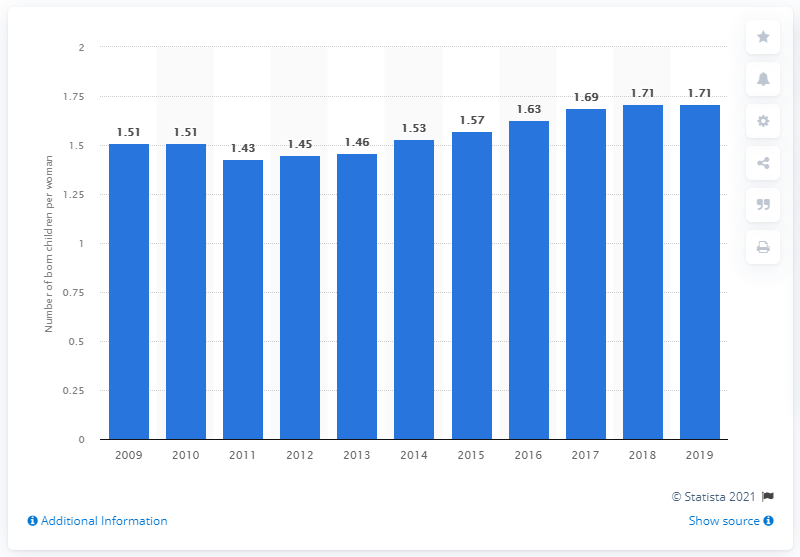Indicate a few pertinent items in this graphic. In 2019, the fertility rate in the Czech Republic was 1.71. This means that there were an average of 1.71 live births per woman in the country during that year. 